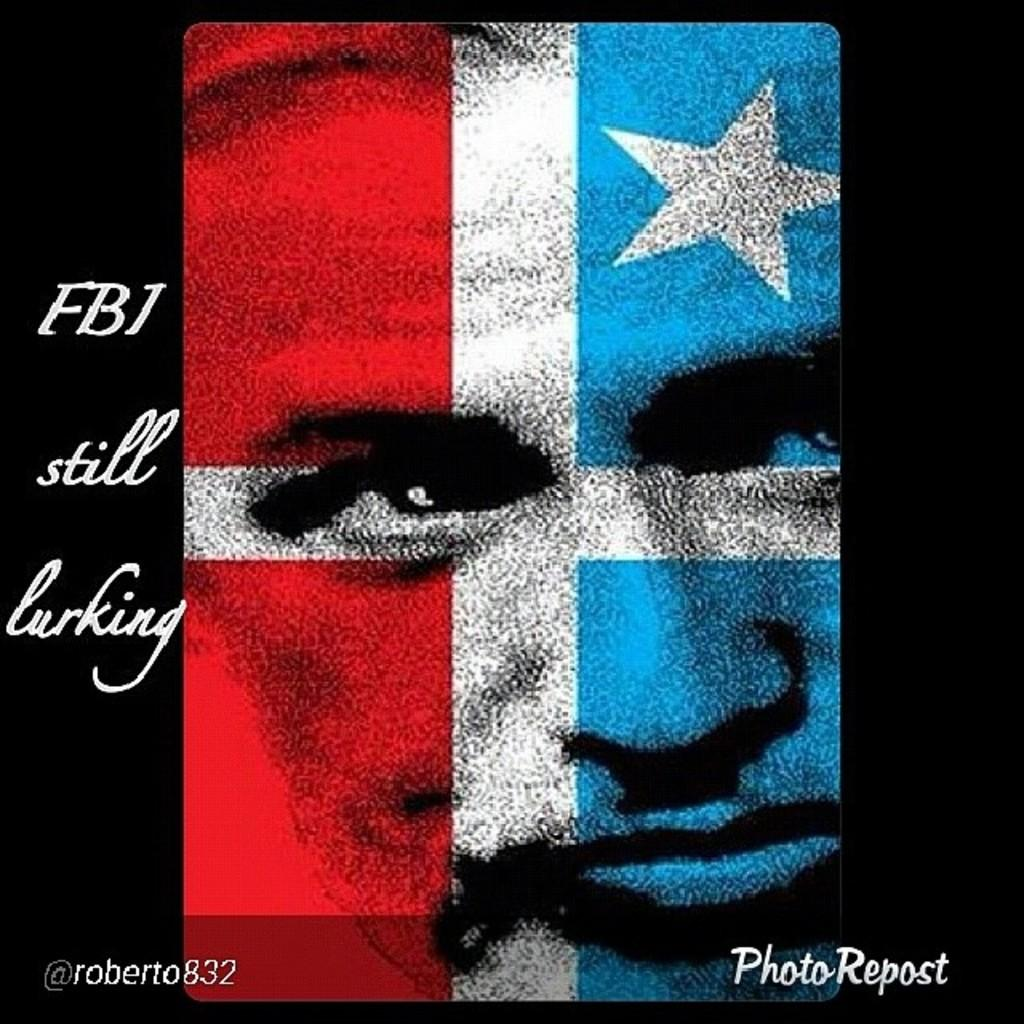What is featured on the poster in the image? The poster has a face and a star on it. Is there any text on the poster? Yes, there is text on the poster. What is the purpose of the watermarks at the bottom of the image? The purpose of the watermarks is not clear from the image, but they may be for copyright or identification purposes. What invention is being demonstrated in the image? There is no invention being demonstrated in the image; it features a poster with a face, star, and text. How is the glue being used in the image? There is no glue present in the image. What type of lead is visible in the image? There is no lead visible in the image. 